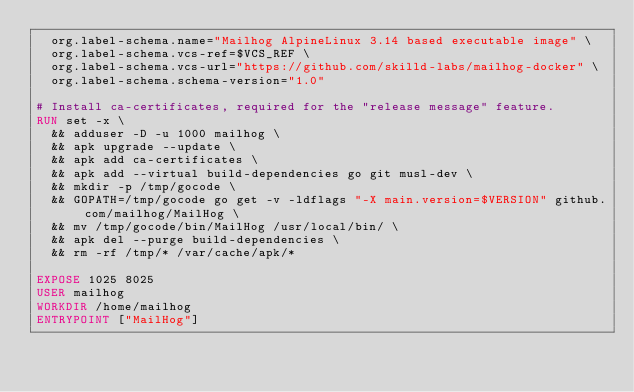<code> <loc_0><loc_0><loc_500><loc_500><_Dockerfile_>  org.label-schema.name="Mailhog AlpineLinux 3.14 based executable image" \
  org.label-schema.vcs-ref=$VCS_REF \
  org.label-schema.vcs-url="https://github.com/skilld-labs/mailhog-docker" \
  org.label-schema.schema-version="1.0"

# Install ca-certificates, required for the "release message" feature.
RUN set -x \
  && adduser -D -u 1000 mailhog \
  && apk upgrade --update \
  && apk add ca-certificates \
  && apk add --virtual build-dependencies go git musl-dev \
  && mkdir -p /tmp/gocode \
  && GOPATH=/tmp/gocode go get -v -ldflags "-X main.version=$VERSION" github.com/mailhog/MailHog \
  && mv /tmp/gocode/bin/MailHog /usr/local/bin/ \
  && apk del --purge build-dependencies \
  && rm -rf /tmp/* /var/cache/apk/*

EXPOSE 1025 8025
USER mailhog
WORKDIR /home/mailhog
ENTRYPOINT ["MailHog"]
</code> 